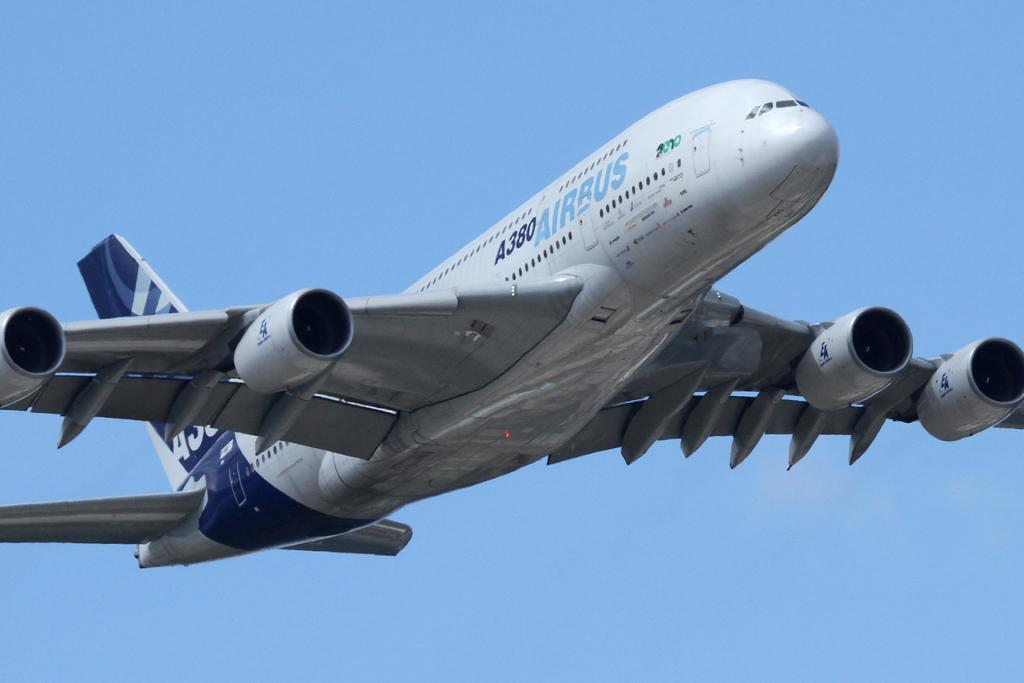<image>
Present a compact description of the photo's key features. a huge Airbus plane is flying through the sky 